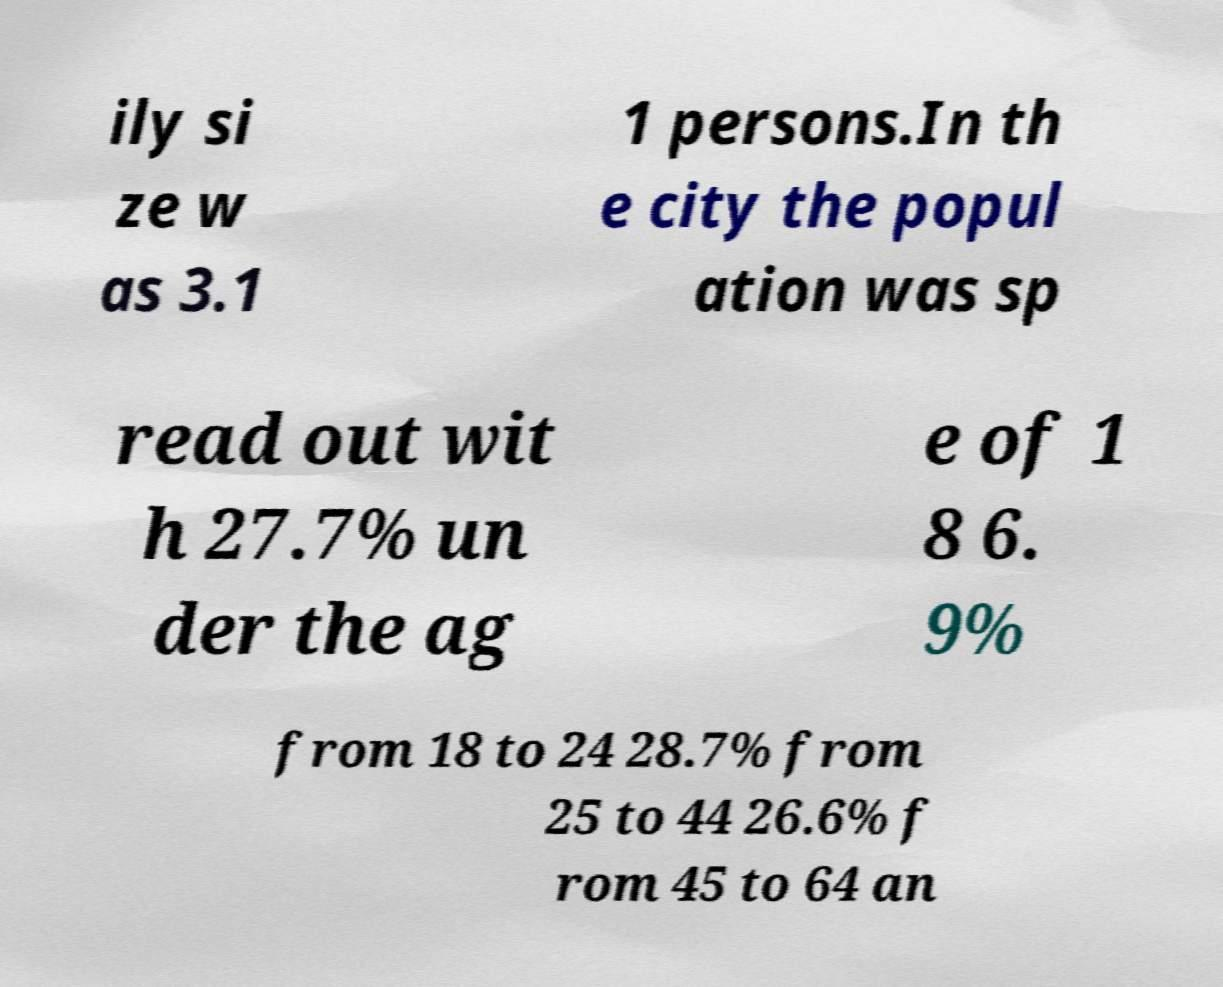Please identify and transcribe the text found in this image. ily si ze w as 3.1 1 persons.In th e city the popul ation was sp read out wit h 27.7% un der the ag e of 1 8 6. 9% from 18 to 24 28.7% from 25 to 44 26.6% f rom 45 to 64 an 